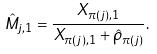Convert formula to latex. <formula><loc_0><loc_0><loc_500><loc_500>\hat { M } _ { j , 1 } = \frac { X _ { \pi ( j ) , 1 } } { X _ { \pi ( j ) , 1 } + \hat { \rho } _ { \pi ( j ) } } .</formula> 